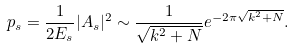<formula> <loc_0><loc_0><loc_500><loc_500>p _ { s } = \frac { 1 } { 2 E _ { s } } | A _ { s } | ^ { 2 } \sim \frac { 1 } { \sqrt { k ^ { 2 } + N } } e ^ { - 2 \pi \sqrt { k ^ { 2 } + N } } .</formula> 